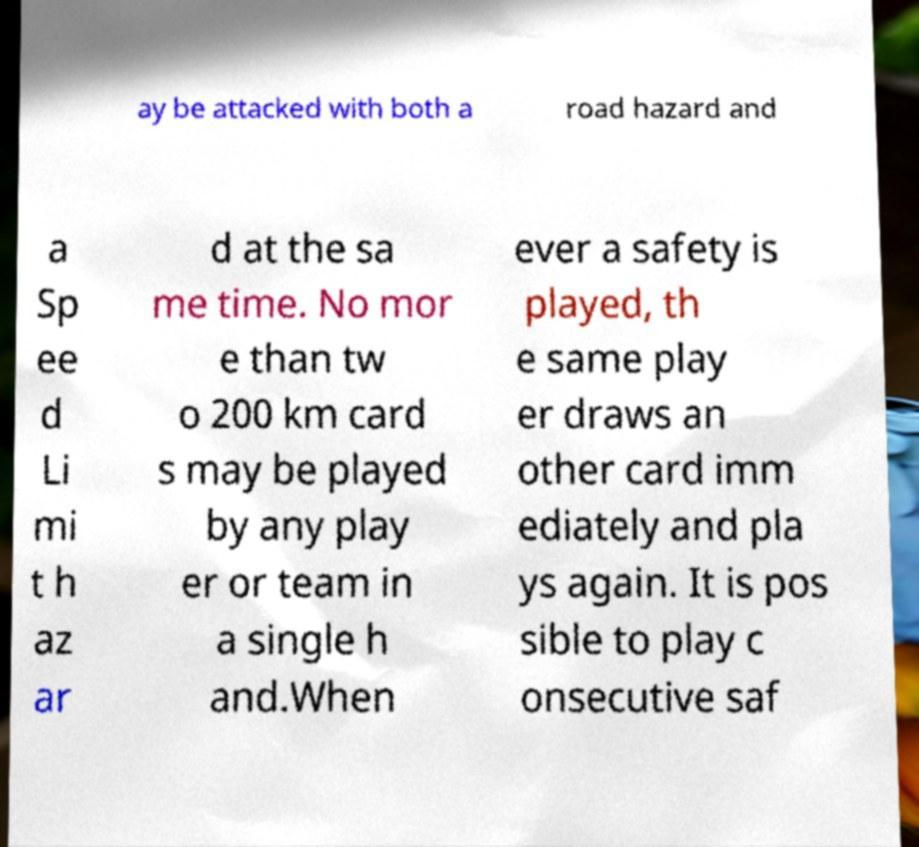Can you read and provide the text displayed in the image?This photo seems to have some interesting text. Can you extract and type it out for me? ay be attacked with both a road hazard and a Sp ee d Li mi t h az ar d at the sa me time. No mor e than tw o 200 km card s may be played by any play er or team in a single h and.When ever a safety is played, th e same play er draws an other card imm ediately and pla ys again. It is pos sible to play c onsecutive saf 